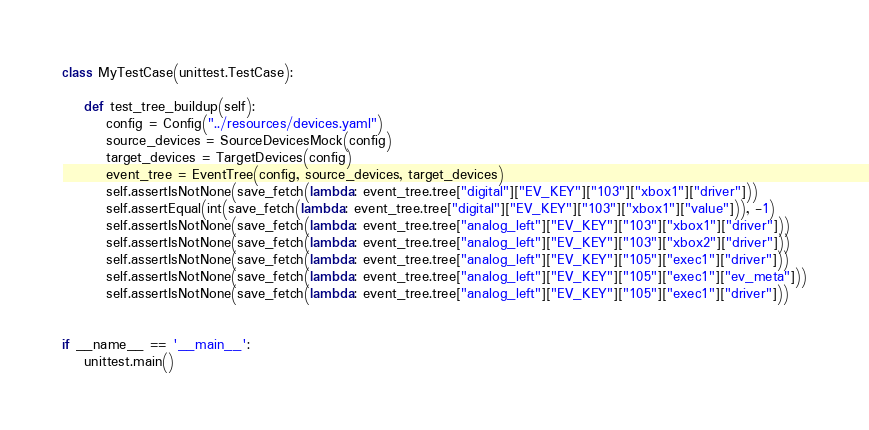<code> <loc_0><loc_0><loc_500><loc_500><_Python_>

class MyTestCase(unittest.TestCase):

    def test_tree_buildup(self):
        config = Config("../resources/devices.yaml")
        source_devices = SourceDevicesMock(config)
        target_devices = TargetDevices(config)
        event_tree = EventTree(config, source_devices, target_devices)
        self.assertIsNotNone(save_fetch(lambda: event_tree.tree["digital"]["EV_KEY"]["103"]["xbox1"]["driver"]))
        self.assertEqual(int(save_fetch(lambda: event_tree.tree["digital"]["EV_KEY"]["103"]["xbox1"]["value"])), -1)
        self.assertIsNotNone(save_fetch(lambda: event_tree.tree["analog_left"]["EV_KEY"]["103"]["xbox1"]["driver"]))
        self.assertIsNotNone(save_fetch(lambda: event_tree.tree["analog_left"]["EV_KEY"]["103"]["xbox2"]["driver"]))
        self.assertIsNotNone(save_fetch(lambda: event_tree.tree["analog_left"]["EV_KEY"]["105"]["exec1"]["driver"]))
        self.assertIsNotNone(save_fetch(lambda: event_tree.tree["analog_left"]["EV_KEY"]["105"]["exec1"]["ev_meta"]))
        self.assertIsNotNone(save_fetch(lambda: event_tree.tree["analog_left"]["EV_KEY"]["105"]["exec1"]["driver"]))


if __name__ == '__main__':
    unittest.main()
</code> 